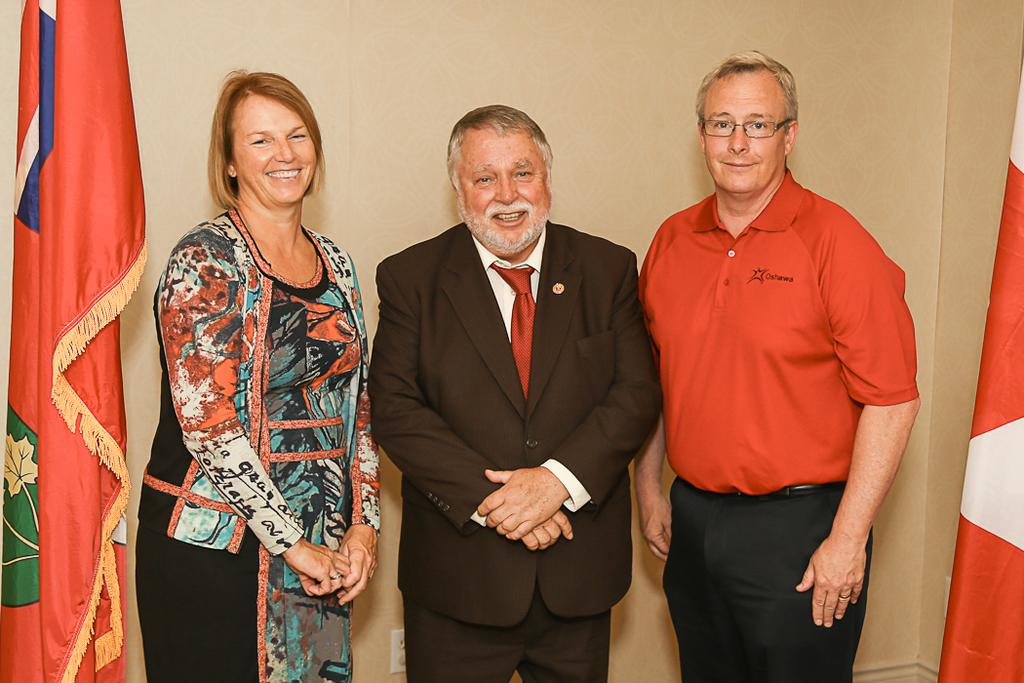What can be observed about the people in the image? There are people standing in the image. Can you describe the attire of one of the individuals? One person is wearing a coat and a tie. What accessory is worn by a man in the image? A man is wearing glasses. What can be seen in the background of the image? There are flags and a wall in the background of the image. What type of zipper can be seen on the apparatus in the image? There is no apparatus or zipper present in the image. What emotion might the people in the image be feeling due to the shame they are experiencing? There is no indication of shame or any specific emotions being experienced by the people in the image. 